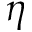Convert formula to latex. <formula><loc_0><loc_0><loc_500><loc_500>\eta</formula> 